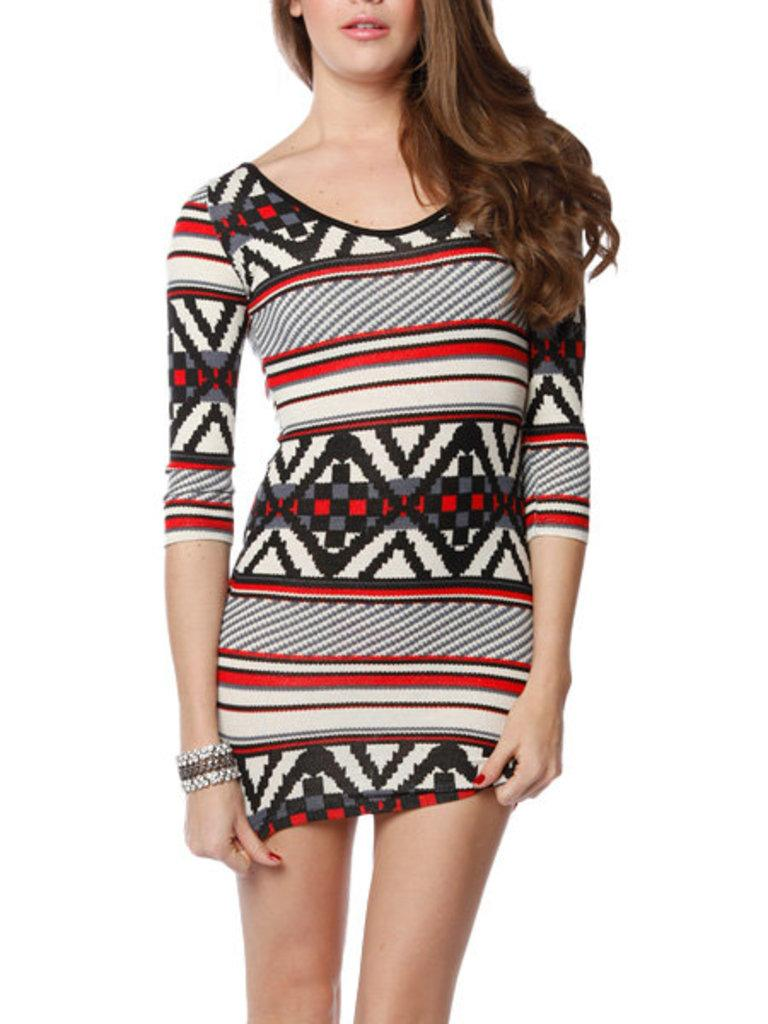What is the main subject of the image? There is a girl in the image. What is the girl doing in the image? The girl is standing. What color is the orange that the girl is holding in the image? There is no orange present in the image; the girl is simply standing. What time does the clock show in the image? There is no clock present in the image. 